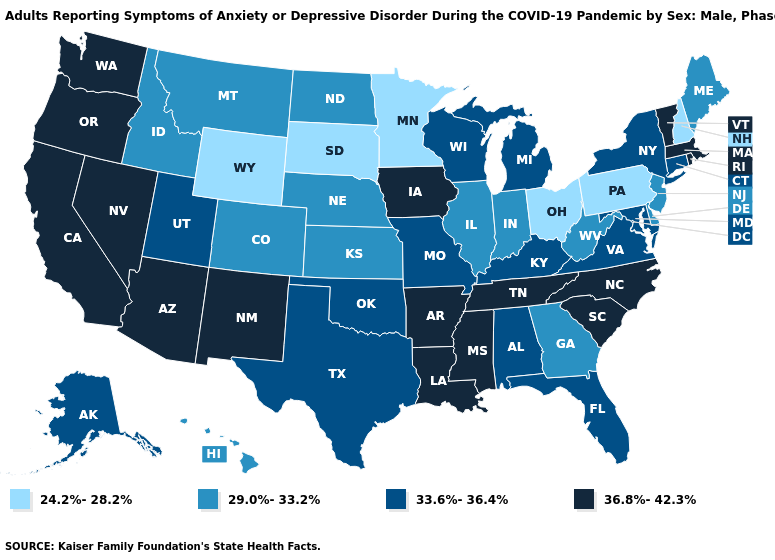Name the states that have a value in the range 29.0%-33.2%?
Be succinct. Colorado, Delaware, Georgia, Hawaii, Idaho, Illinois, Indiana, Kansas, Maine, Montana, Nebraska, New Jersey, North Dakota, West Virginia. Name the states that have a value in the range 29.0%-33.2%?
Short answer required. Colorado, Delaware, Georgia, Hawaii, Idaho, Illinois, Indiana, Kansas, Maine, Montana, Nebraska, New Jersey, North Dakota, West Virginia. Name the states that have a value in the range 24.2%-28.2%?
Write a very short answer. Minnesota, New Hampshire, Ohio, Pennsylvania, South Dakota, Wyoming. Name the states that have a value in the range 29.0%-33.2%?
Give a very brief answer. Colorado, Delaware, Georgia, Hawaii, Idaho, Illinois, Indiana, Kansas, Maine, Montana, Nebraska, New Jersey, North Dakota, West Virginia. Does Virginia have the same value as Hawaii?
Keep it brief. No. Which states have the lowest value in the Northeast?
Be succinct. New Hampshire, Pennsylvania. What is the value of Illinois?
Quick response, please. 29.0%-33.2%. Among the states that border Delaware , does Pennsylvania have the lowest value?
Give a very brief answer. Yes. Which states have the highest value in the USA?
Quick response, please. Arizona, Arkansas, California, Iowa, Louisiana, Massachusetts, Mississippi, Nevada, New Mexico, North Carolina, Oregon, Rhode Island, South Carolina, Tennessee, Vermont, Washington. Which states have the lowest value in the USA?
Concise answer only. Minnesota, New Hampshire, Ohio, Pennsylvania, South Dakota, Wyoming. Among the states that border Wyoming , which have the highest value?
Keep it brief. Utah. Is the legend a continuous bar?
Answer briefly. No. Which states hav the highest value in the South?
Concise answer only. Arkansas, Louisiana, Mississippi, North Carolina, South Carolina, Tennessee. Name the states that have a value in the range 36.8%-42.3%?
Keep it brief. Arizona, Arkansas, California, Iowa, Louisiana, Massachusetts, Mississippi, Nevada, New Mexico, North Carolina, Oregon, Rhode Island, South Carolina, Tennessee, Vermont, Washington. Does Virginia have the highest value in the South?
Keep it brief. No. 